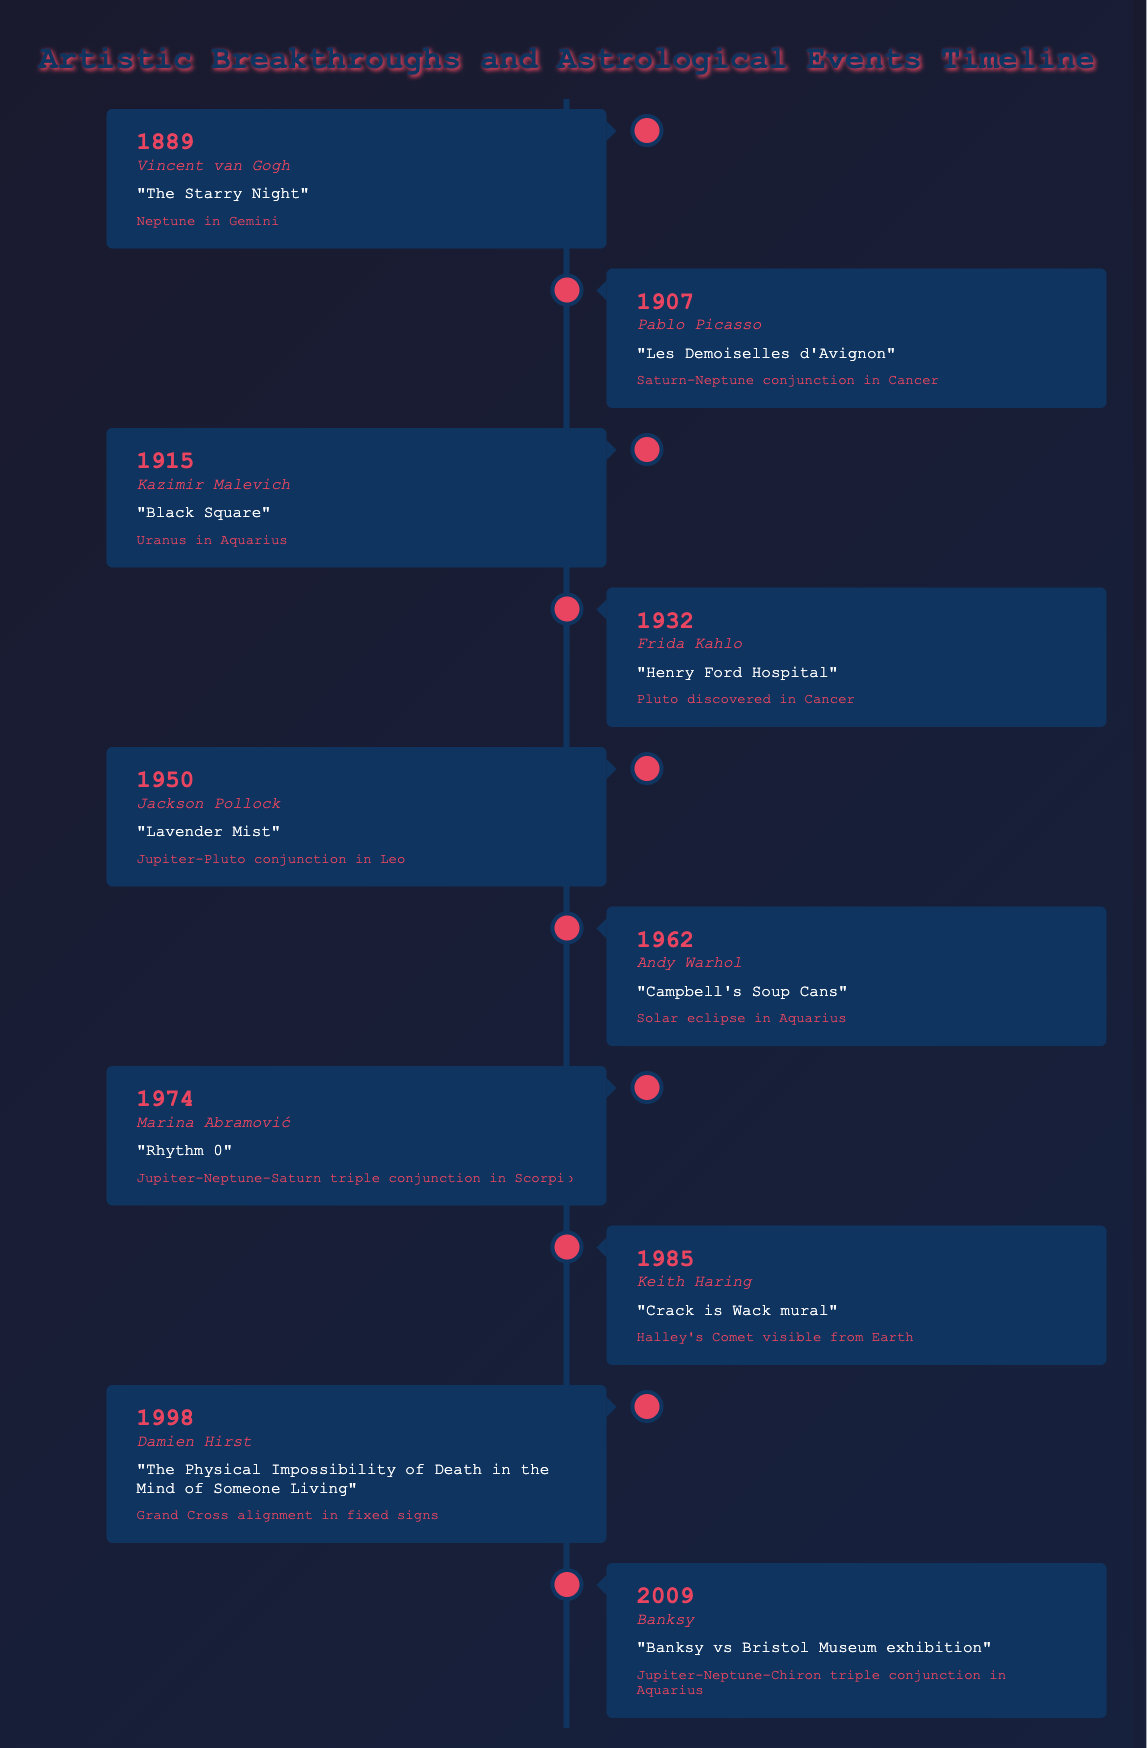What year did Vincent van Gogh have his breakthrough? The table lists the breakthrough year for Vincent van Gogh as 1889.
Answer: 1889 Which artist's breakthrough coincided with Neptune in Gemini? According to the table, Vincent van Gogh had his breakthrough "The Starry Night" in 1889, when Neptune was in Gemini.
Answer: Vincent van Gogh What was the artistic breakthrough of Pablo Picasso? From the table, Pablo Picasso's breakthrough was "Les Demoiselles d'Avignon," which he achieved in 1907.
Answer: Les Demoiselles d'Avignon Did any artist have their breakthrough during a solar eclipse? The table shows that Andy Warhol's breakthrough occurred in a year with a solar eclipse in Aquarius, which was in 1962, so yes.
Answer: Yes Which artist had a breakthrough under the astrological event "Halley's Comet visible from Earth"? The table specifies that Keith Haring had his breakthrough with the "Crack is Wack mural" in 1985 during the appearance of Halley's Comet.
Answer: Keith Haring How many artists had breakthroughs related to conjunctions? By reviewing the table, I see there are four events that mention conjunctions: Pablo Picasso (Saturn-Neptune), Jackson Pollock (Jupiter-Pluto), Marina Abramović (Jupiter-Neptune-Saturn), and Banksy (Jupiter-Neptune-Chiron). Therefore, there are four artists.
Answer: 4 Who had a breakthrough in a year when Uranus was in Aquarius? The table indicates that Kazimir Malevich had his breakthrough "Black Square" in 1915, when Uranus was in Aquarius.
Answer: Kazimir Malevich Which artist had the most recent breakthrough listed in the table? The most recent breakthrough listed is from Banksy in 2009, according to the timeline presented.
Answer: Banksy Was there any breakthrough that occurred in 1932? From the table, Frida Kahlo had her breakthrough in 1932 with "Henry Ford Hospital." So yes, there was a breakthrough that year.
Answer: Yes 